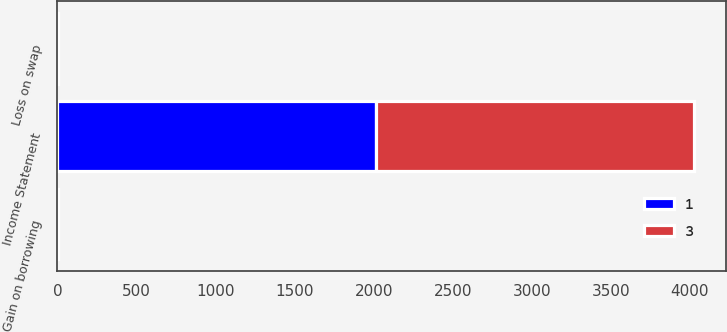<chart> <loc_0><loc_0><loc_500><loc_500><stacked_bar_chart><ecel><fcel>Income Statement<fcel>Loss on swap<fcel>Gain on borrowing<nl><fcel>1<fcel>2015<fcel>1<fcel>1<nl><fcel>3<fcel>2013<fcel>3<fcel>3<nl></chart> 